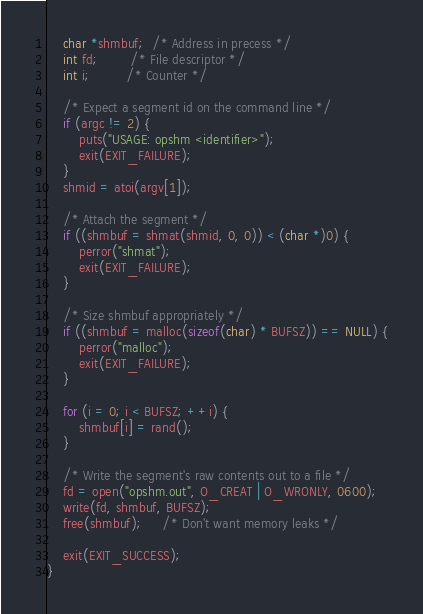Convert code to text. <code><loc_0><loc_0><loc_500><loc_500><_C_>    char *shmbuf;  /* Address in precess */
    int fd;        /* File descriptor */
    int i;         /* Counter */

    /* Expect a segment id on the command line */
    if (argc != 2) {
        puts("USAGE: opshm <identifier>");
        exit(EXIT_FAILURE);
    }
    shmid = atoi(argv[1]);

    /* Attach the segment */
    if ((shmbuf = shmat(shmid, 0, 0)) < (char *)0) {
        perror("shmat");
        exit(EXIT_FAILURE);
    }

    /* Size shmbuf appropriately */
    if ((shmbuf = malloc(sizeof(char) * BUFSZ)) == NULL) {
        perror("malloc");
        exit(EXIT_FAILURE);
    }

    for (i = 0; i < BUFSZ; ++i) {
        shmbuf[i] = rand();
    }

    /* Write the segment's raw contents out to a file */
    fd = open("opshm.out", O_CREAT | O_WRONLY, 0600);
    write(fd, shmbuf, BUFSZ);
    free(shmbuf);     /* Don't want memory leaks */

    exit(EXIT_SUCCESS);
}
</code> 